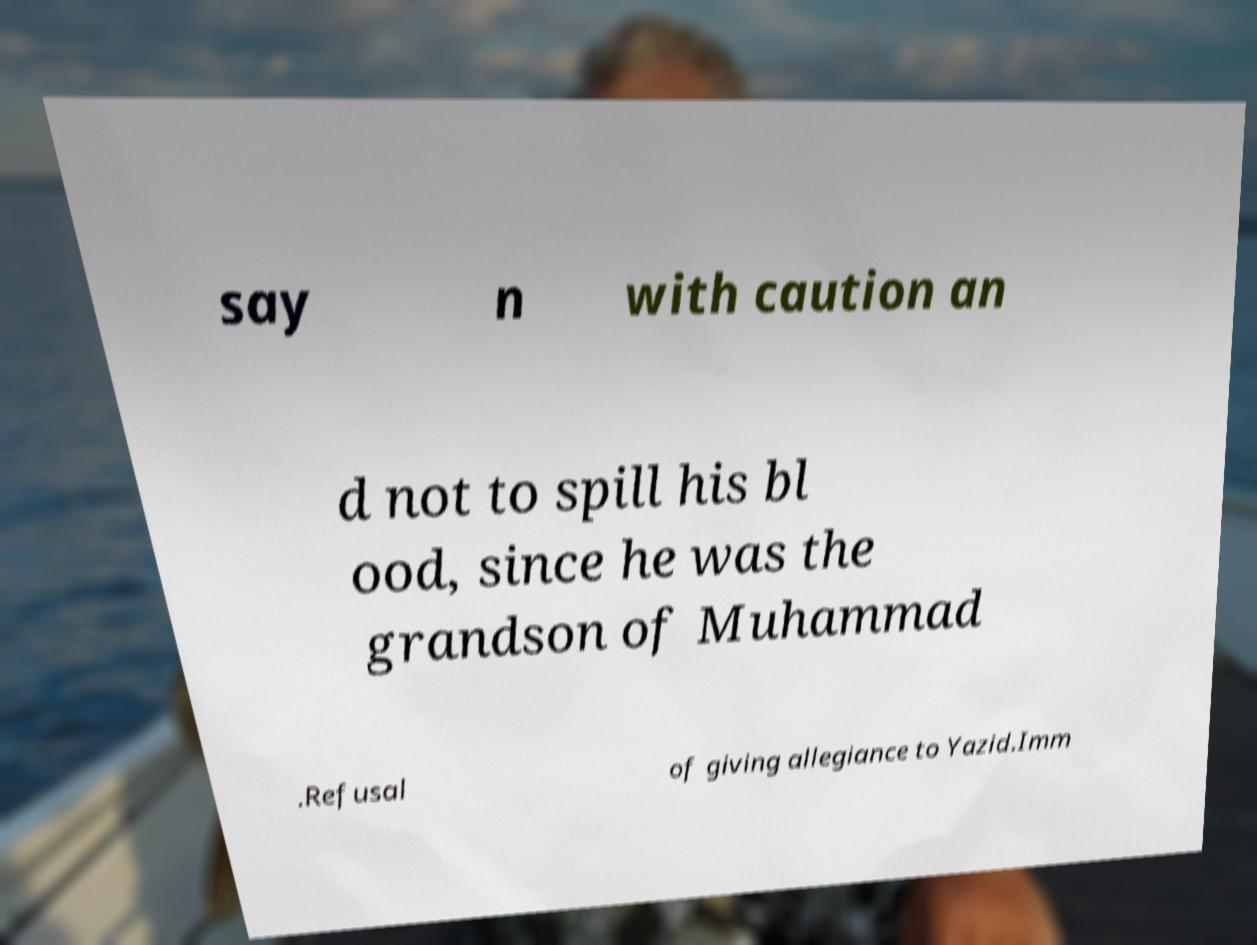Please identify and transcribe the text found in this image. say n with caution an d not to spill his bl ood, since he was the grandson of Muhammad .Refusal of giving allegiance to Yazid.Imm 